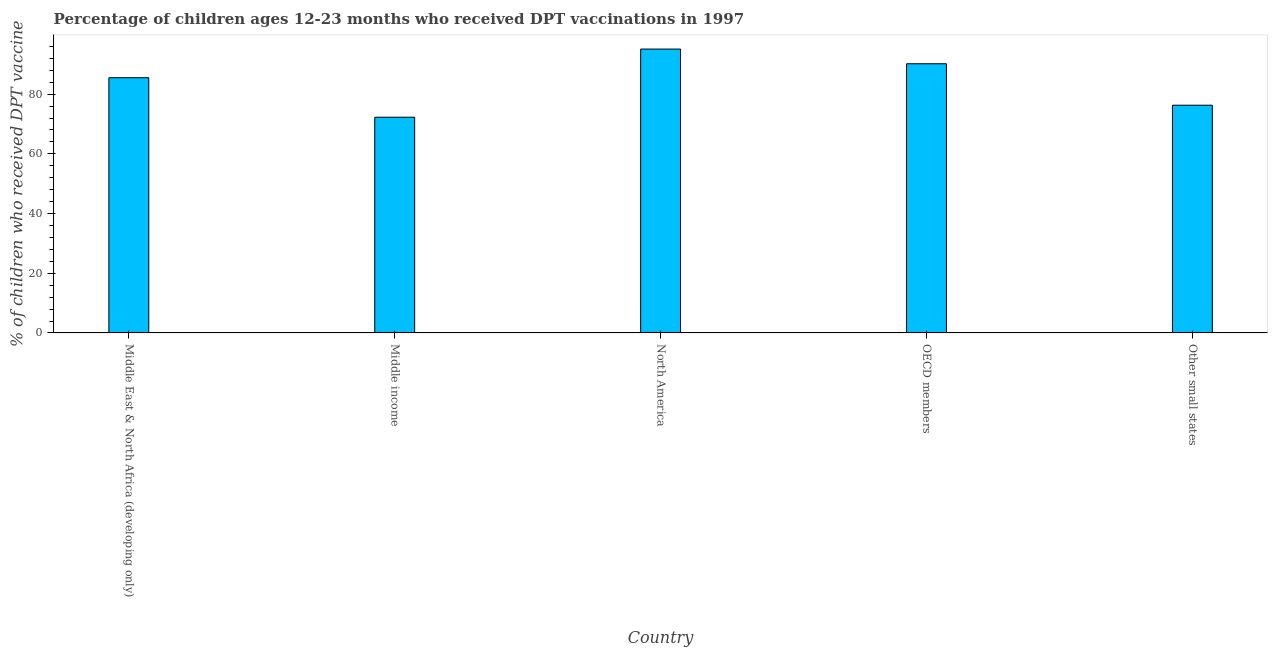Does the graph contain any zero values?
Give a very brief answer. No. Does the graph contain grids?
Provide a short and direct response. No. What is the title of the graph?
Give a very brief answer. Percentage of children ages 12-23 months who received DPT vaccinations in 1997. What is the label or title of the Y-axis?
Provide a succinct answer. % of children who received DPT vaccine. What is the percentage of children who received dpt vaccine in Middle income?
Give a very brief answer. 72.27. Across all countries, what is the maximum percentage of children who received dpt vaccine?
Your response must be concise. 95.11. Across all countries, what is the minimum percentage of children who received dpt vaccine?
Offer a terse response. 72.27. What is the sum of the percentage of children who received dpt vaccine?
Give a very brief answer. 419.36. What is the difference between the percentage of children who received dpt vaccine in Middle East & North Africa (developing only) and Middle income?
Offer a terse response. 13.24. What is the average percentage of children who received dpt vaccine per country?
Provide a short and direct response. 83.87. What is the median percentage of children who received dpt vaccine?
Offer a very short reply. 85.51. What is the ratio of the percentage of children who received dpt vaccine in Middle East & North Africa (developing only) to that in Other small states?
Your response must be concise. 1.12. Is the percentage of children who received dpt vaccine in Middle income less than that in OECD members?
Your answer should be compact. Yes. What is the difference between the highest and the second highest percentage of children who received dpt vaccine?
Make the answer very short. 4.92. What is the difference between the highest and the lowest percentage of children who received dpt vaccine?
Provide a succinct answer. 22.84. In how many countries, is the percentage of children who received dpt vaccine greater than the average percentage of children who received dpt vaccine taken over all countries?
Give a very brief answer. 3. How many bars are there?
Your answer should be very brief. 5. Are all the bars in the graph horizontal?
Your answer should be compact. No. What is the % of children who received DPT vaccine of Middle East & North Africa (developing only)?
Offer a terse response. 85.51. What is the % of children who received DPT vaccine of Middle income?
Ensure brevity in your answer.  72.27. What is the % of children who received DPT vaccine of North America?
Ensure brevity in your answer.  95.11. What is the % of children who received DPT vaccine in OECD members?
Provide a succinct answer. 90.18. What is the % of children who received DPT vaccine in Other small states?
Give a very brief answer. 76.29. What is the difference between the % of children who received DPT vaccine in Middle East & North Africa (developing only) and Middle income?
Provide a short and direct response. 13.24. What is the difference between the % of children who received DPT vaccine in Middle East & North Africa (developing only) and North America?
Offer a very short reply. -9.59. What is the difference between the % of children who received DPT vaccine in Middle East & North Africa (developing only) and OECD members?
Provide a short and direct response. -4.67. What is the difference between the % of children who received DPT vaccine in Middle East & North Africa (developing only) and Other small states?
Provide a short and direct response. 9.22. What is the difference between the % of children who received DPT vaccine in Middle income and North America?
Give a very brief answer. -22.84. What is the difference between the % of children who received DPT vaccine in Middle income and OECD members?
Provide a succinct answer. -17.91. What is the difference between the % of children who received DPT vaccine in Middle income and Other small states?
Offer a very short reply. -4.03. What is the difference between the % of children who received DPT vaccine in North America and OECD members?
Offer a very short reply. 4.92. What is the difference between the % of children who received DPT vaccine in North America and Other small states?
Give a very brief answer. 18.81. What is the difference between the % of children who received DPT vaccine in OECD members and Other small states?
Your response must be concise. 13.89. What is the ratio of the % of children who received DPT vaccine in Middle East & North Africa (developing only) to that in Middle income?
Provide a succinct answer. 1.18. What is the ratio of the % of children who received DPT vaccine in Middle East & North Africa (developing only) to that in North America?
Make the answer very short. 0.9. What is the ratio of the % of children who received DPT vaccine in Middle East & North Africa (developing only) to that in OECD members?
Ensure brevity in your answer.  0.95. What is the ratio of the % of children who received DPT vaccine in Middle East & North Africa (developing only) to that in Other small states?
Your answer should be very brief. 1.12. What is the ratio of the % of children who received DPT vaccine in Middle income to that in North America?
Your answer should be compact. 0.76. What is the ratio of the % of children who received DPT vaccine in Middle income to that in OECD members?
Provide a short and direct response. 0.8. What is the ratio of the % of children who received DPT vaccine in Middle income to that in Other small states?
Offer a very short reply. 0.95. What is the ratio of the % of children who received DPT vaccine in North America to that in OECD members?
Offer a very short reply. 1.05. What is the ratio of the % of children who received DPT vaccine in North America to that in Other small states?
Ensure brevity in your answer.  1.25. What is the ratio of the % of children who received DPT vaccine in OECD members to that in Other small states?
Give a very brief answer. 1.18. 